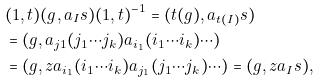Convert formula to latex. <formula><loc_0><loc_0><loc_500><loc_500>& ( 1 , t ) ( g , a _ { I } s ) ( 1 , t ) ^ { - 1 } = ( t ( g ) , a _ { t ( I ) } s ) \\ & = ( g , a _ { j 1 } ( j _ { 1 } \cdots j _ { k } ) a _ { i _ { 1 } } ( i _ { 1 } \cdots i _ { k } ) \cdots ) \\ & = ( g , z a _ { i _ { 1 } } ( i _ { 1 } \cdots i _ { k } ) a _ { j _ { 1 } } ( j _ { 1 } \cdots j _ { k } ) \cdots ) = ( g , z a _ { I } s ) ,</formula> 